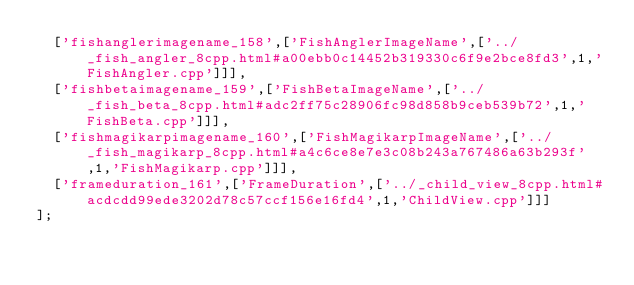Convert code to text. <code><loc_0><loc_0><loc_500><loc_500><_JavaScript_>  ['fishanglerimagename_158',['FishAnglerImageName',['../_fish_angler_8cpp.html#a00ebb0c14452b319330c6f9e2bce8fd3',1,'FishAngler.cpp']]],
  ['fishbetaimagename_159',['FishBetaImageName',['../_fish_beta_8cpp.html#adc2ff75c28906fc98d858b9ceb539b72',1,'FishBeta.cpp']]],
  ['fishmagikarpimagename_160',['FishMagikarpImageName',['../_fish_magikarp_8cpp.html#a4c6ce8e7e3c08b243a767486a63b293f',1,'FishMagikarp.cpp']]],
  ['frameduration_161',['FrameDuration',['../_child_view_8cpp.html#acdcdd99ede3202d78c57ccf156e16fd4',1,'ChildView.cpp']]]
];
</code> 